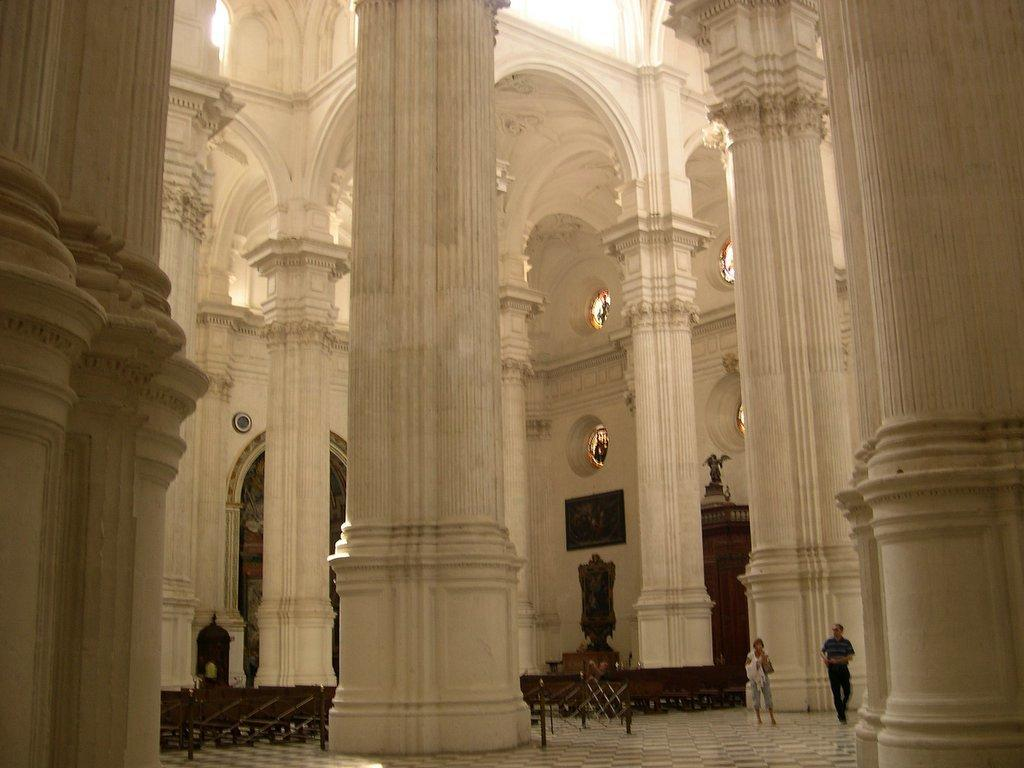What type of location is depicted in the image? The image shows an inside view of a building. What architectural features can be seen in the image? There are pillars visible in the image. Are there any people present in the image? Yes, there are persons standing in the image. What else can be seen in the image besides the people and pillars? There is a wall visible in the image. What brand of toothpaste is being advertised on the wall in the image? There is no toothpaste or advertisement present on the wall in the image. How many oranges are being held by the persons in the image? There are no oranges visible in the image; the persons are not holding any. 